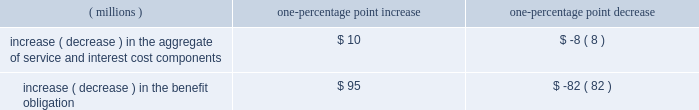Decreased by one percentage point per year , such increases or decreases would have the following effects: .
Increase ( decrease ) in the aggregate of service and interest cost components $ 10 $ ( 8 ) increase ( decrease ) in the benefit obligation $ 95 $ ( 82 ) the company also incurred costs for multi-employer pen- sion plans of $ 2 million in 2003 and $ 1 million for both 2002 and 2001 .
Multi-employer healthcare costs totaled $ 1 million in each of the years 2003 , 2002 and 2001 .
The company has a deferred compensation plan for certain key managers which allows them to defer a portion of their compensation in a phantom ppg stock account or other phantom investment accounts .
The amount deferred earns a return based on the investment options selected by the participant .
The amount owed to participants is an unfunded and unsecured general obligation of the company .
Upon retirement , death , disability or termination of employment , the compensation deferred and related accumulated earnings are distributed in cash or in ppg stock , based on the accounts selected by the participant .
The plan provides participants with investment alterna- tives and the ability to transfer amounts between the phan- tom non-ppg stock investment accounts .
To mitigate the impact on compensation expense of changes in the market value of the liability , the company purchased a portfolio of marketable securities that mirror the phantom non-ppg stock investment accounts selected by the participants except the money market accounts .
The changes in market value of these securities are also included in earnings .
Trading will occur in this portfolio to align the securities held with the participant 2019s phantom non-ppg stock invest- ment accounts except the money market accounts .
The cost of the deferred compensation plan , comprised of dividend equivalents accrued on the phantom ppg stock account , investment income and the change in market value of the liability , was a loss in 2003 of $ 13 million , and income of $ 9 million and $ 6 million in 2002 and 2001 , respectively .
These amounts are included in 201cselling , gener- al and administrative 201d in the accompanying statement of income .
The change in market value of the investment portfolio in 2003 was income of $ 13 million , and a loss of $ 10 million and $ 7 million in 2002 and 2001 , respectively , and is also included in 201cselling , general and administrative . 201d the company 2019s obligations under this plan , which are included in 201cother liabilities 201d in the accompanying balance sheet , were $ 100 million and $ 84 million as of dec .
31 , 2003 and 2002 , respectively , and the investments in mar- ketable securities , which are included in 201cinvestments 201d in the accompanying balance sheet , were $ 68 million and $ 53 million as of dec .
31 , 2003 and 2002 , respectively .
13 .
Commitments and contingent liabilities ppg is involved in a number of lawsuits and claims , both actual and potential , including some that it has asserted against others , in which substantial monetary damages are sought .
These lawsuits and claims , the most significant of which are described below , relate to product liability , con- tract , patent , environmental , antitrust and other matters arising out of the conduct of ppg 2019s business .
To the extent that these lawsuits and claims involve personal injury and property damage , ppg believes it has adequate insurance ; however , certain of ppg 2019s insurers are contesting coverage with respect to some of these claims , and other insurers , as they had prior to the asbestos settlement described below , may contest coverage with respect to some of the asbestos claims if the settlement is not implemented .
Ppg 2019s lawsuits and claims against others include claims against insurers and other third parties with respect to actual and contin- gent losses related to environmental , asbestos and other matters .
The result of any future litigation of such lawsuits and claims is inherently unpredictable .
However , management believes that , in the aggregate , the outcome of all lawsuits and claims involving ppg , including asbestos-related claims in the event the settlement described below does not become effective , will not have a material effect on ppg 2019s consolidated financial position or liquidity ; however , any such outcome may be material to the results of operations of any particular period in which costs , if any , are recognized .
The company has been named as a defendant , along with various other co-defendants , in a number of antitrust lawsuits , including suits in various state and federal courts alleging that ppg acted with competitors to fix prices and allocate markets in the automotive refinish industry and a federal class action suit relating to certain glass products .
The federal automotive refinish cases have been consoli- dated in the u.s .
District court for the eastern district of pennsylvania located in philadelphia , pa. , but these proceed- ings are at an early stage .
The state automotive refinish cases have either been stayed pending resolution of the federal proceedings or have been dismissed .
All of the initial defendants in the glass class action antitrust case other than ppg have settled .
On may 29 , 2003 , the u.s .
District court for the western district of pennsylvania located in pittsburgh , pa .
Granted ppg 2019s motion for summary judgment dismissing the claims against ppg in the glass class action antitrust case .
The plaintiffs in that case have appealed that 2003 annual report and form 10-k 25a0 ppg industries , inc .
43 .
Without the change in market value of the investment portfolio in 2003 , what would the company 2019s obligations be under the deferred comp plan , in millions? 
Computations: (100 + 13)
Answer: 113.0. 